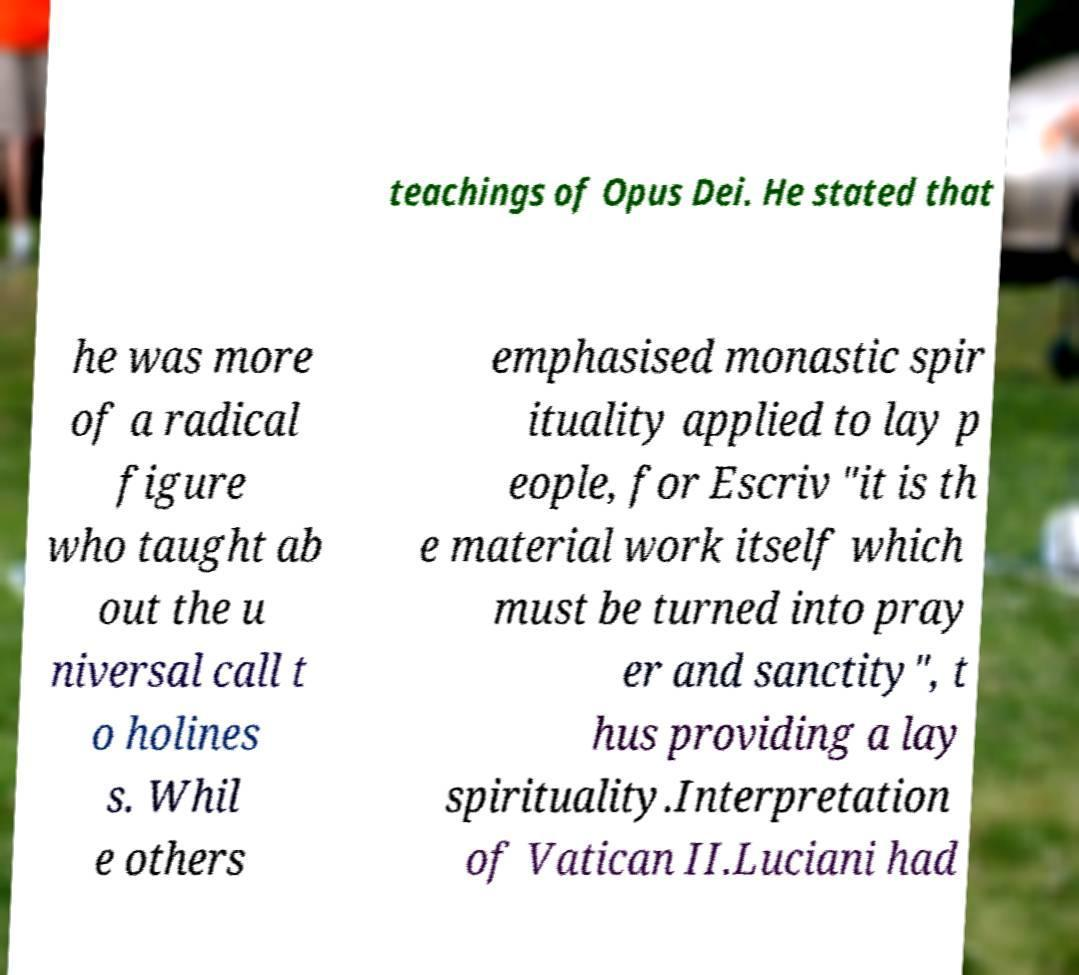Could you assist in decoding the text presented in this image and type it out clearly? teachings of Opus Dei. He stated that he was more of a radical figure who taught ab out the u niversal call t o holines s. Whil e others emphasised monastic spir ituality applied to lay p eople, for Escriv "it is th e material work itself which must be turned into pray er and sanctity", t hus providing a lay spirituality.Interpretation of Vatican II.Luciani had 